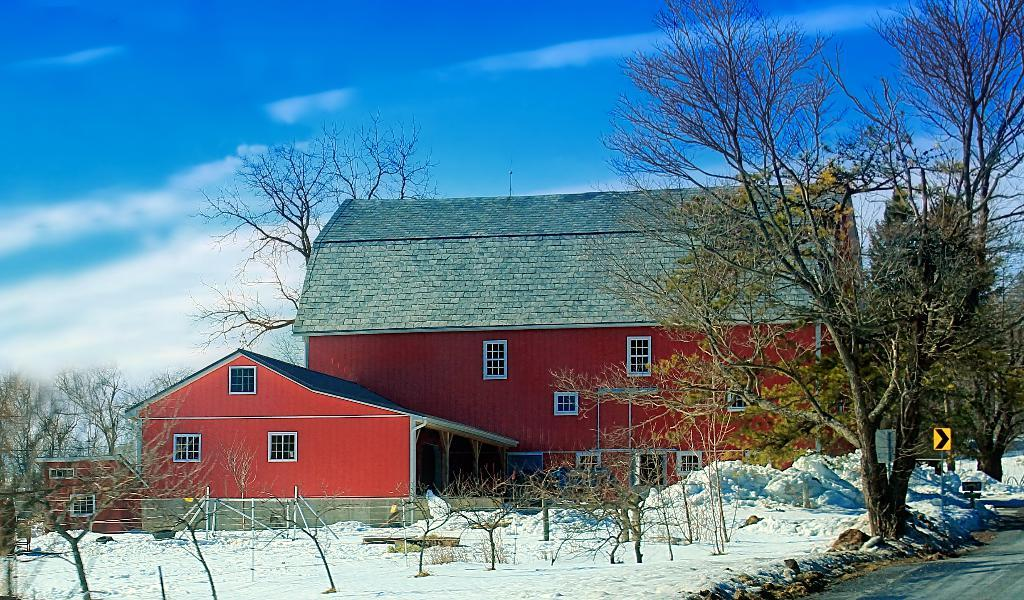What type of structures can be seen in the image? There are houses in the image. What features can be observed on the houses? The houses have windows. What other objects are present in the image? There are poles, sign boards, pillars, trees, and snow visible in the image. What can be seen in the background of the image? The sky is visible in the background of the image. How many waves can be seen crashing on the shore in the image? There are no waves present in the image; it features houses, poles, sign boards, pillars, trees, snow, and the sky. What type of mailbox is attached to the house on the left side of the image? There is no mailbox present on the house on the left side of the image. 